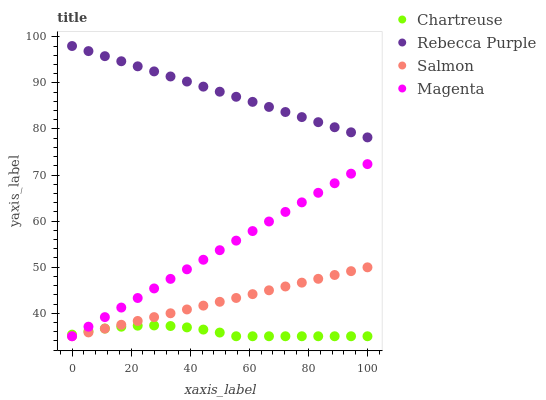Does Chartreuse have the minimum area under the curve?
Answer yes or no. Yes. Does Rebecca Purple have the maximum area under the curve?
Answer yes or no. Yes. Does Salmon have the minimum area under the curve?
Answer yes or no. No. Does Salmon have the maximum area under the curve?
Answer yes or no. No. Is Salmon the smoothest?
Answer yes or no. Yes. Is Chartreuse the roughest?
Answer yes or no. Yes. Is Rebecca Purple the smoothest?
Answer yes or no. No. Is Rebecca Purple the roughest?
Answer yes or no. No. Does Chartreuse have the lowest value?
Answer yes or no. Yes. Does Rebecca Purple have the lowest value?
Answer yes or no. No. Does Rebecca Purple have the highest value?
Answer yes or no. Yes. Does Salmon have the highest value?
Answer yes or no. No. Is Magenta less than Rebecca Purple?
Answer yes or no. Yes. Is Rebecca Purple greater than Salmon?
Answer yes or no. Yes. Does Chartreuse intersect Magenta?
Answer yes or no. Yes. Is Chartreuse less than Magenta?
Answer yes or no. No. Is Chartreuse greater than Magenta?
Answer yes or no. No. Does Magenta intersect Rebecca Purple?
Answer yes or no. No. 